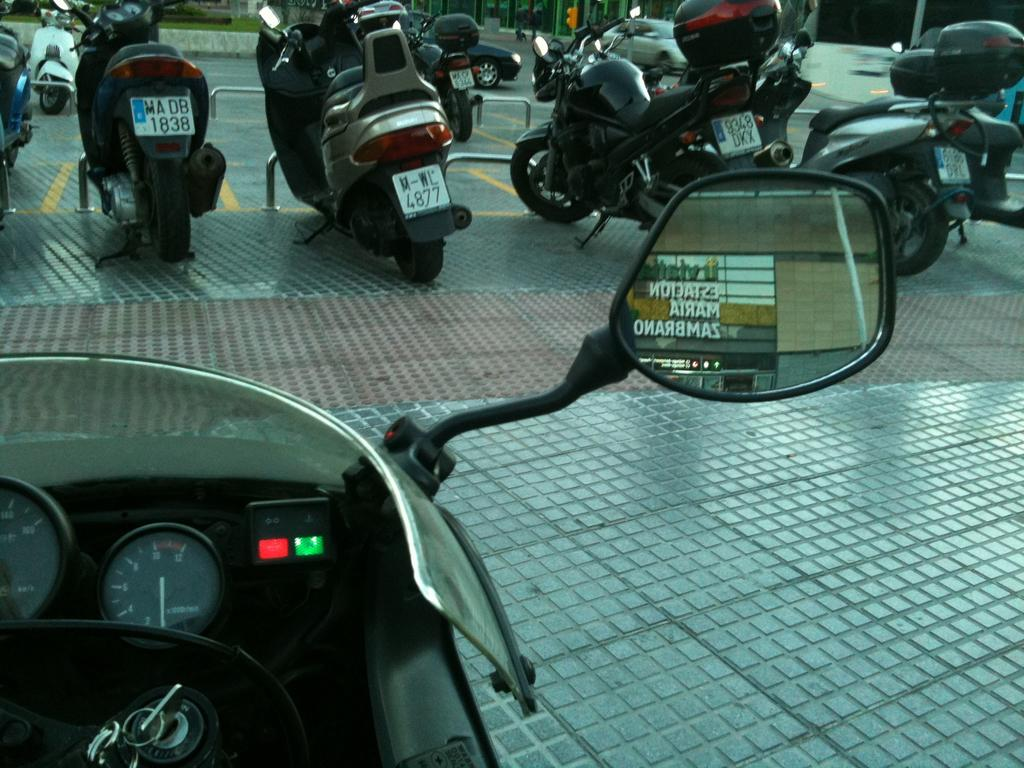What is the main subject of the image? The main subject of the image is the side mirror of a vehicle. What else can be seen in the background of the image? There are other vehicles and objects visible in the background of the image. How much money is being exchanged between the vehicles in the image? There is no indication of money being exchanged in the image; it only shows the side mirror of a vehicle and other vehicles and objects in the background. 